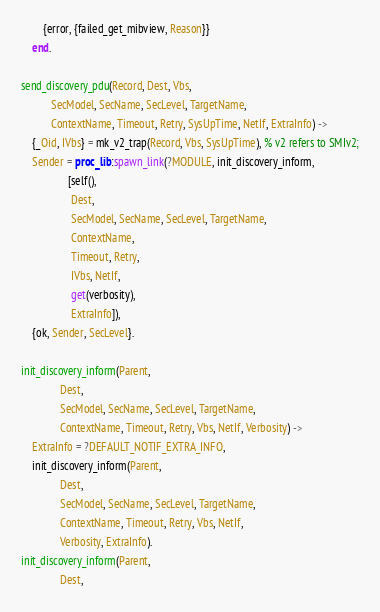<code> <loc_0><loc_0><loc_500><loc_500><_Erlang_>	    {error, {failed_get_mibview, Reason}}
    end.

send_discovery_pdu(Record, Dest, Vbs, 
		   SecModel, SecName, SecLevel, TargetName, 
		   ContextName, Timeout, Retry, SysUpTime, NetIf, ExtraInfo) ->
    {_Oid, IVbs} = mk_v2_trap(Record, Vbs, SysUpTime), % v2 refers to SMIv2;
    Sender = proc_lib:spawn_link(?MODULE, init_discovery_inform,
				 [self(), 
				  Dest, 
				  SecModel, SecName, SecLevel, TargetName,
				  ContextName, 
				  Timeout, Retry, 
				  IVbs, NetIf, 
				  get(verbosity), 
				  ExtraInfo]),
    {ok, Sender, SecLevel}.

init_discovery_inform(Parent, 
		      Dest, 
		      SecModel, SecName, SecLevel, TargetName, 
		      ContextName, Timeout, Retry, Vbs, NetIf, Verbosity) ->
    ExtraInfo = ?DEFAULT_NOTIF_EXTRA_INFO, 
    init_discovery_inform(Parent, 
			  Dest, 
			  SecModel, SecName, SecLevel, TargetName, 
			  ContextName, Timeout, Retry, Vbs, NetIf, 
			  Verbosity, ExtraInfo).
init_discovery_inform(Parent, 
		      Dest, </code> 